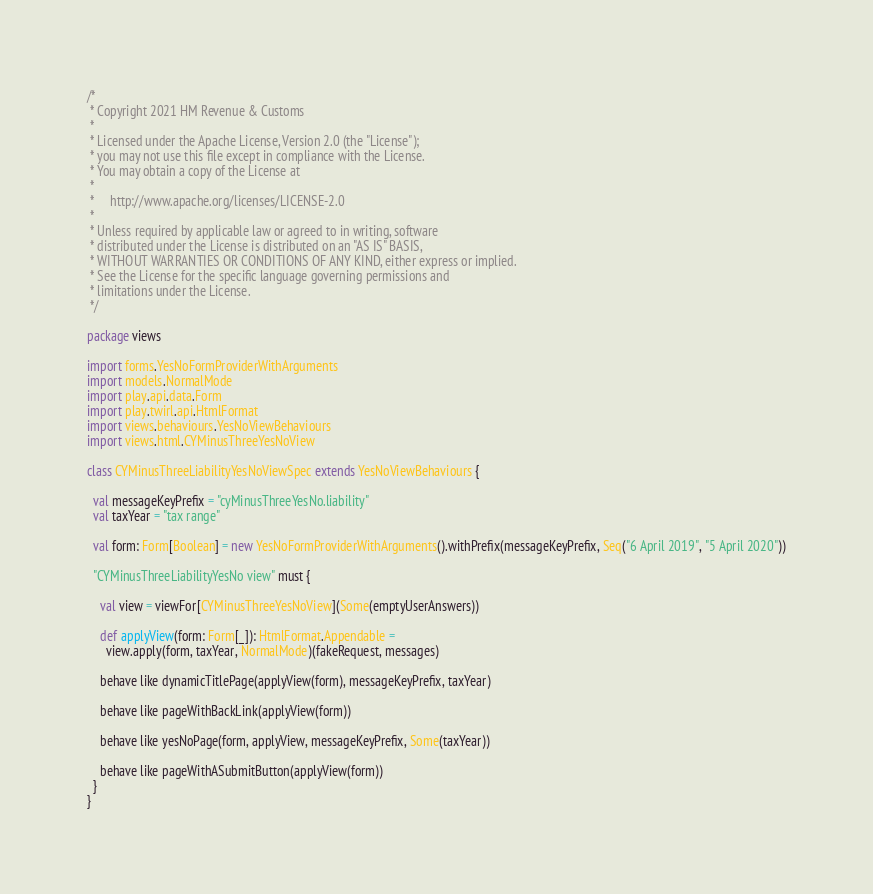<code> <loc_0><loc_0><loc_500><loc_500><_Scala_>/*
 * Copyright 2021 HM Revenue & Customs
 *
 * Licensed under the Apache License, Version 2.0 (the "License");
 * you may not use this file except in compliance with the License.
 * You may obtain a copy of the License at
 *
 *     http://www.apache.org/licenses/LICENSE-2.0
 *
 * Unless required by applicable law or agreed to in writing, software
 * distributed under the License is distributed on an "AS IS" BASIS,
 * WITHOUT WARRANTIES OR CONDITIONS OF ANY KIND, either express or implied.
 * See the License for the specific language governing permissions and
 * limitations under the License.
 */

package views

import forms.YesNoFormProviderWithArguments
import models.NormalMode
import play.api.data.Form
import play.twirl.api.HtmlFormat
import views.behaviours.YesNoViewBehaviours
import views.html.CYMinusThreeYesNoView

class CYMinusThreeLiabilityYesNoViewSpec extends YesNoViewBehaviours {

  val messageKeyPrefix = "cyMinusThreeYesNo.liability"
  val taxYear = "tax range"

  val form: Form[Boolean] = new YesNoFormProviderWithArguments().withPrefix(messageKeyPrefix, Seq("6 April 2019", "5 April 2020"))

  "CYMinusThreeLiabilityYesNo view" must {

    val view = viewFor[CYMinusThreeYesNoView](Some(emptyUserAnswers))

    def applyView(form: Form[_]): HtmlFormat.Appendable =
      view.apply(form, taxYear, NormalMode)(fakeRequest, messages)

    behave like dynamicTitlePage(applyView(form), messageKeyPrefix, taxYear)

    behave like pageWithBackLink(applyView(form))

    behave like yesNoPage(form, applyView, messageKeyPrefix, Some(taxYear))

    behave like pageWithASubmitButton(applyView(form))
  }
}
</code> 